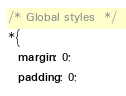Convert code to text. <code><loc_0><loc_0><loc_500><loc_500><_CSS_>/* Global styles  */
*{
  margin: 0;
  padding: 0;</code> 